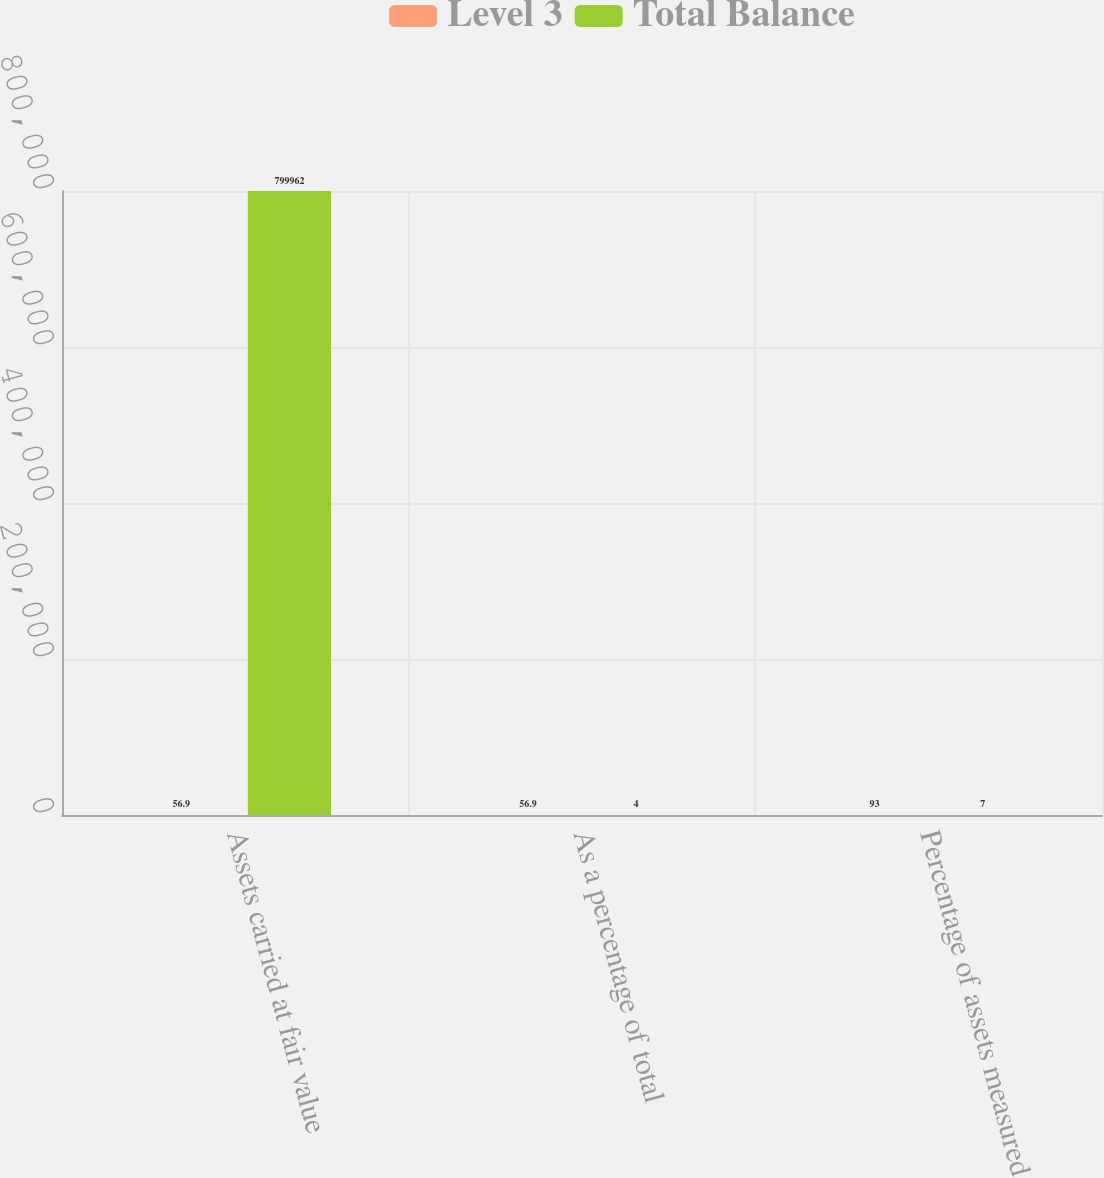Convert chart. <chart><loc_0><loc_0><loc_500><loc_500><stacked_bar_chart><ecel><fcel>Assets carried at fair value<fcel>As a percentage of total<fcel>Percentage of assets measured<nl><fcel>Level 3<fcel>56.9<fcel>56.9<fcel>93<nl><fcel>Total Balance<fcel>799962<fcel>4<fcel>7<nl></chart> 